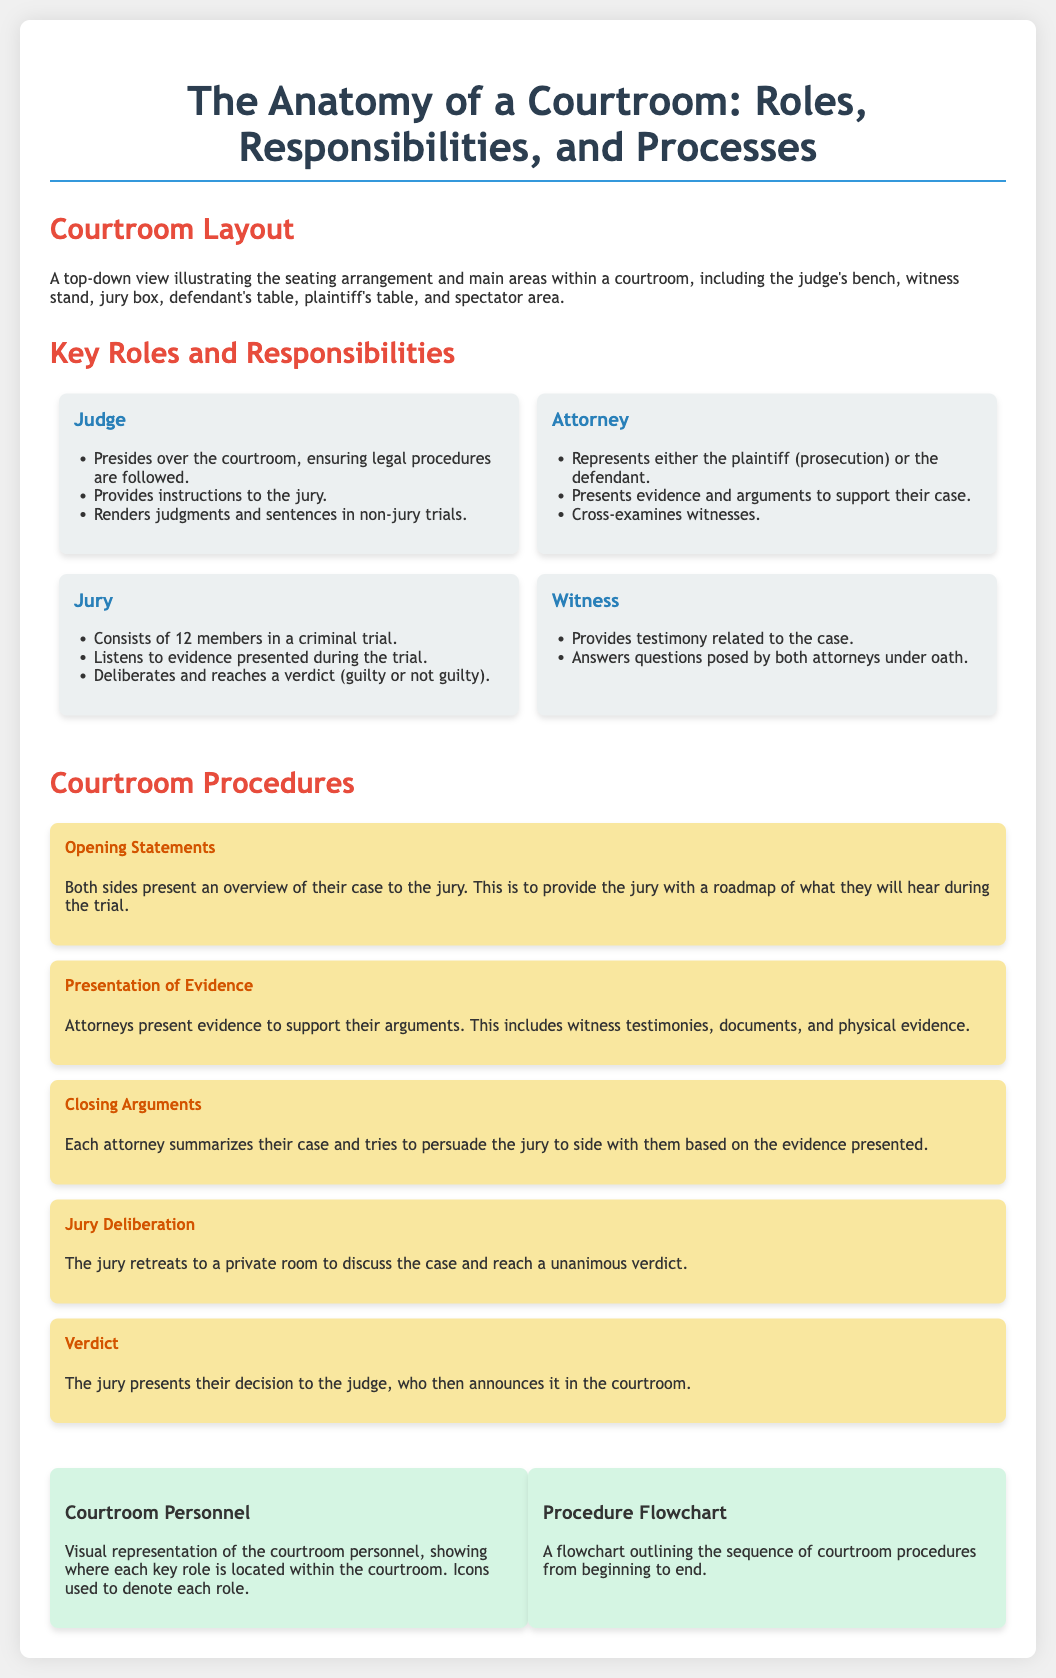What is the main focus of the poster? The title indicates that the main focus is on the roles, responsibilities, and processes within a courtroom.
Answer: The Anatomy of a Courtroom: Roles, Responsibilities, and Processes Who presides over the courtroom? The role of the Judge is described as the one who presides over the courtroom.
Answer: Judge How many members are in a jury for a criminal trial? The document states that the jury consists of 12 members in a criminal trial.
Answer: 12 What is the purpose of opening statements? The document explains that the purpose is to provide the jury with a roadmap of what they will hear during the trial.
Answer: Overview of the case What follows the presentation of evidence? The sequence of courtroom procedures indicates that closing arguments follow the presentation of evidence.
Answer: Closing Arguments What visual element shows courtroom personnel arrangement? The visual representation that details the courtroom personnel's locations is labeled as Courtroom Personnel.
Answer: Courtroom Personnel What is the last step in the courtroom procedure? According to the document, the final step in the courtroom procedure is the verdict presentation.
Answer: Verdict What role is responsible for rendering judgments? The roles section indicates that the Judge is responsible for rendering judgments in non-jury trials.
Answer: Judge 